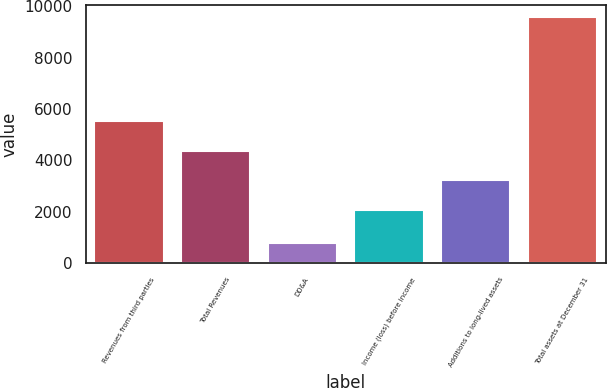Convert chart. <chart><loc_0><loc_0><loc_500><loc_500><bar_chart><fcel>Revenues from third parties<fcel>Total Revenues<fcel>DD&A<fcel>Income (loss) before income<fcel>Additions to long-lived assets<fcel>Total assets at December 31<nl><fcel>5538.9<fcel>4379.6<fcel>791<fcel>2061<fcel>3220.3<fcel>9589<nl></chart> 